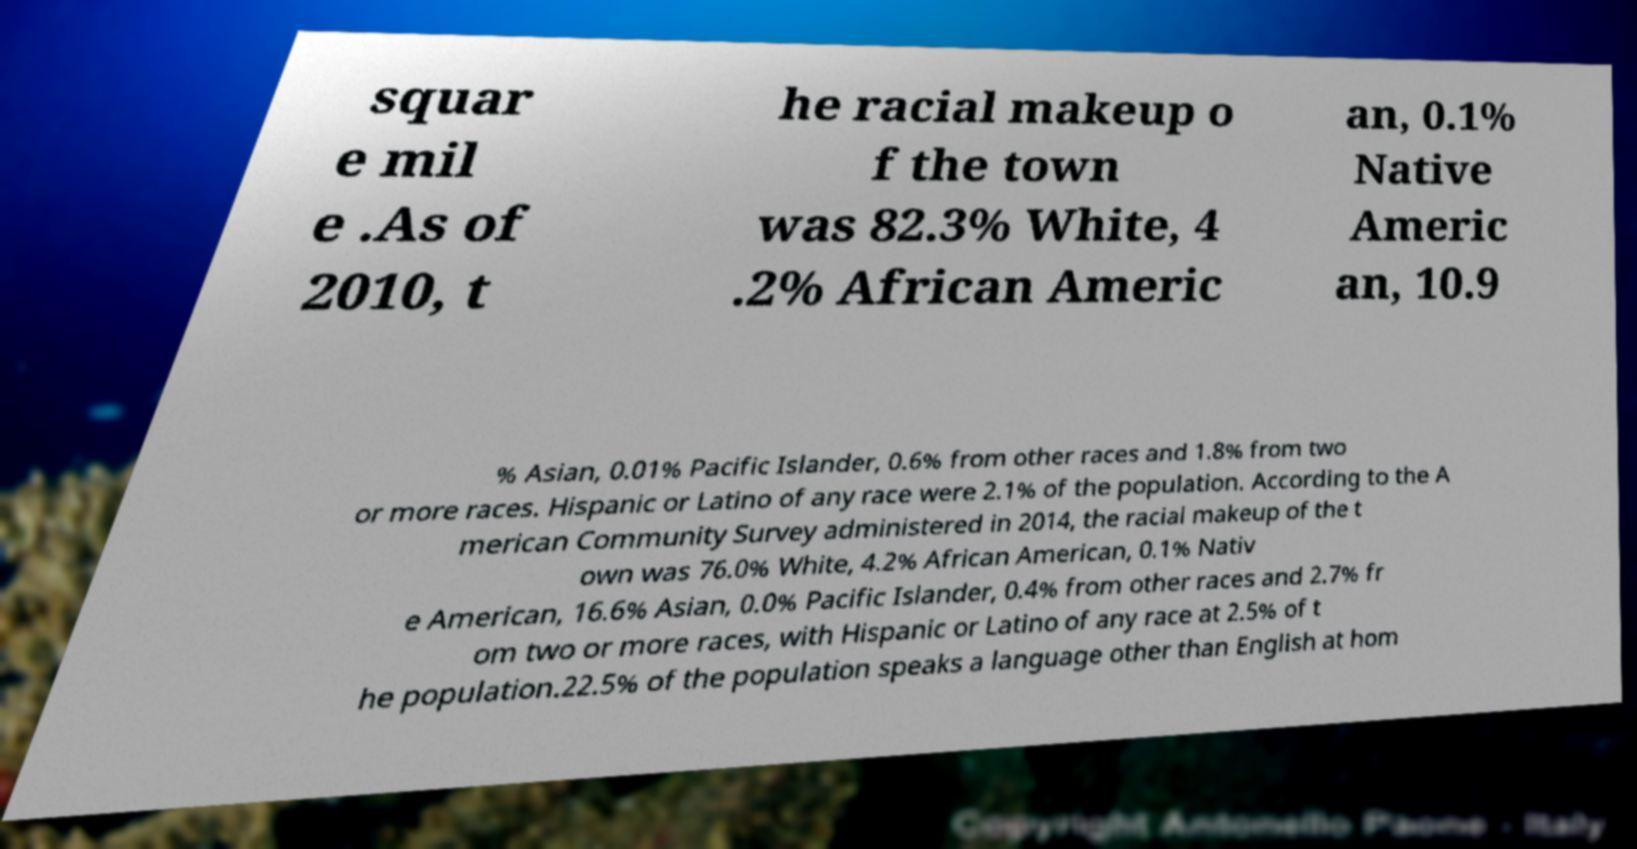Could you assist in decoding the text presented in this image and type it out clearly? squar e mil e .As of 2010, t he racial makeup o f the town was 82.3% White, 4 .2% African Americ an, 0.1% Native Americ an, 10.9 % Asian, 0.01% Pacific Islander, 0.6% from other races and 1.8% from two or more races. Hispanic or Latino of any race were 2.1% of the population. According to the A merican Community Survey administered in 2014, the racial makeup of the t own was 76.0% White, 4.2% African American, 0.1% Nativ e American, 16.6% Asian, 0.0% Pacific Islander, 0.4% from other races and 2.7% fr om two or more races, with Hispanic or Latino of any race at 2.5% of t he population.22.5% of the population speaks a language other than English at hom 